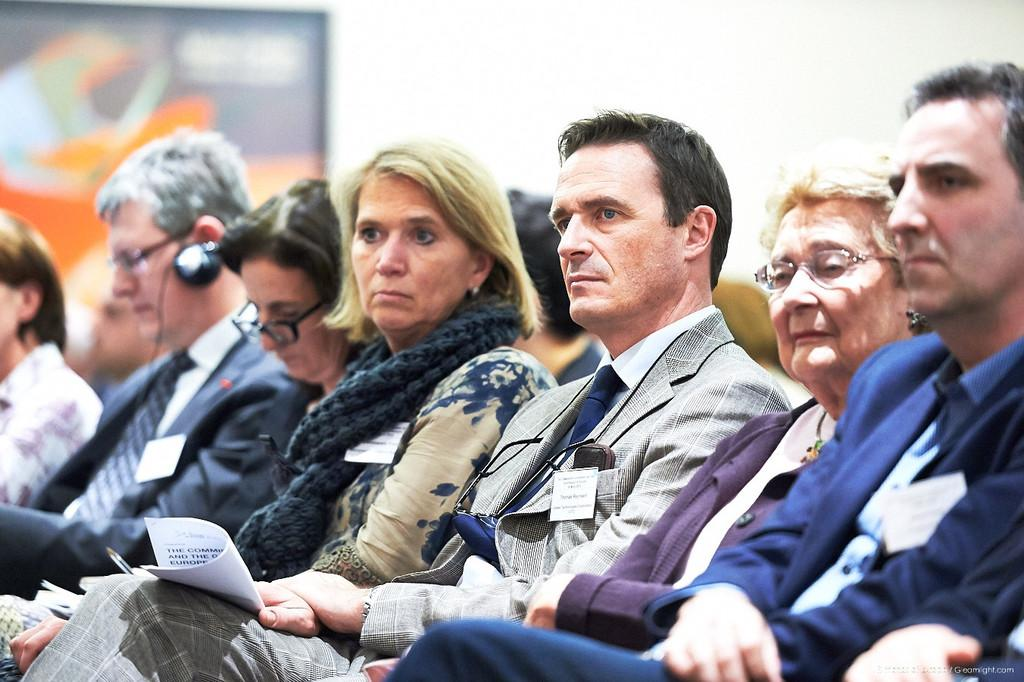What are the people in the image doing? The people in the image are sitting. What can be observed about the clothing of the people in the image? The people are wearing different color dresses. What objects are some of the people holding in the image? Some people are holding papers in the image. What can be seen in the background of the image? There is a white wall visible in the background of the image. Can you tell me how many kittens are sitting on the rail in the image? There is no rail or kittens present in the image. Who is the expert sitting among the people in the image? The provided facts do not mention any experts or their presence in the image. 